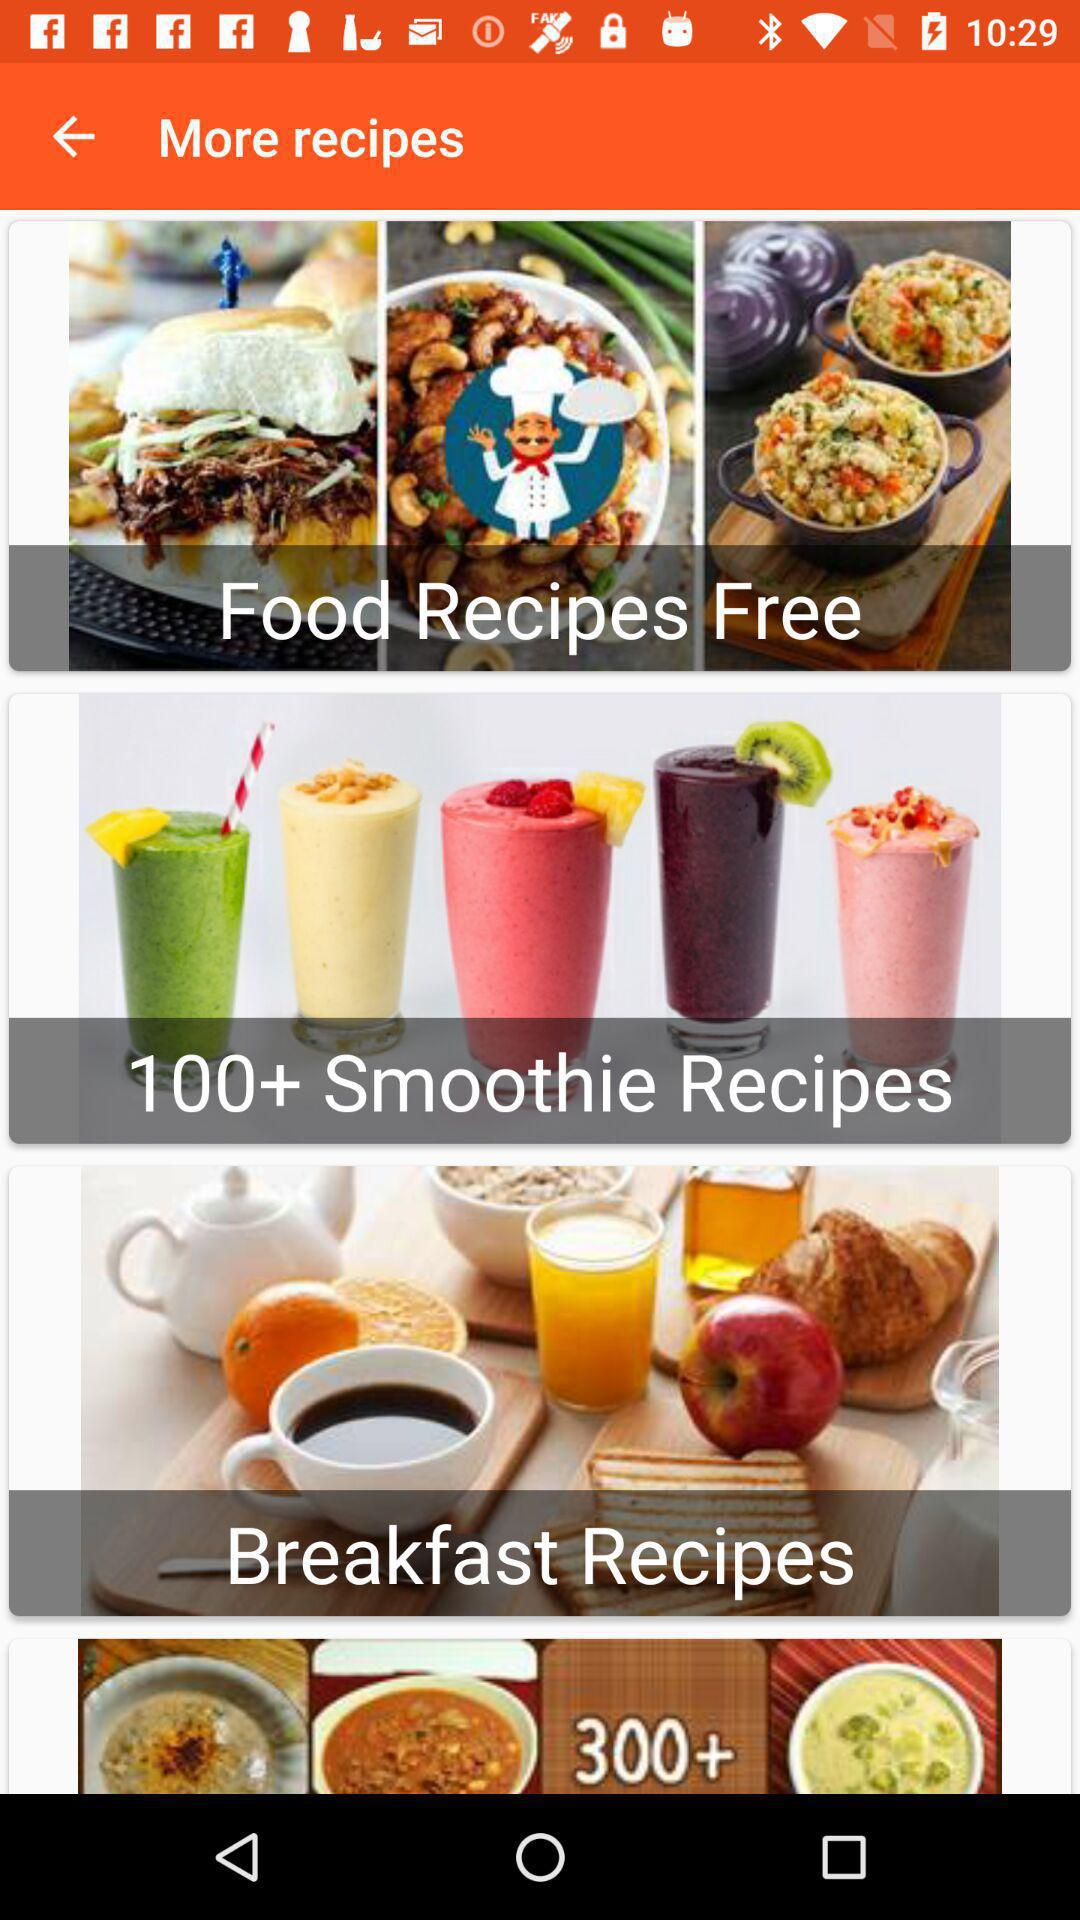How many smoothie recipes are there? There are more than 100 smoothie recipes. 